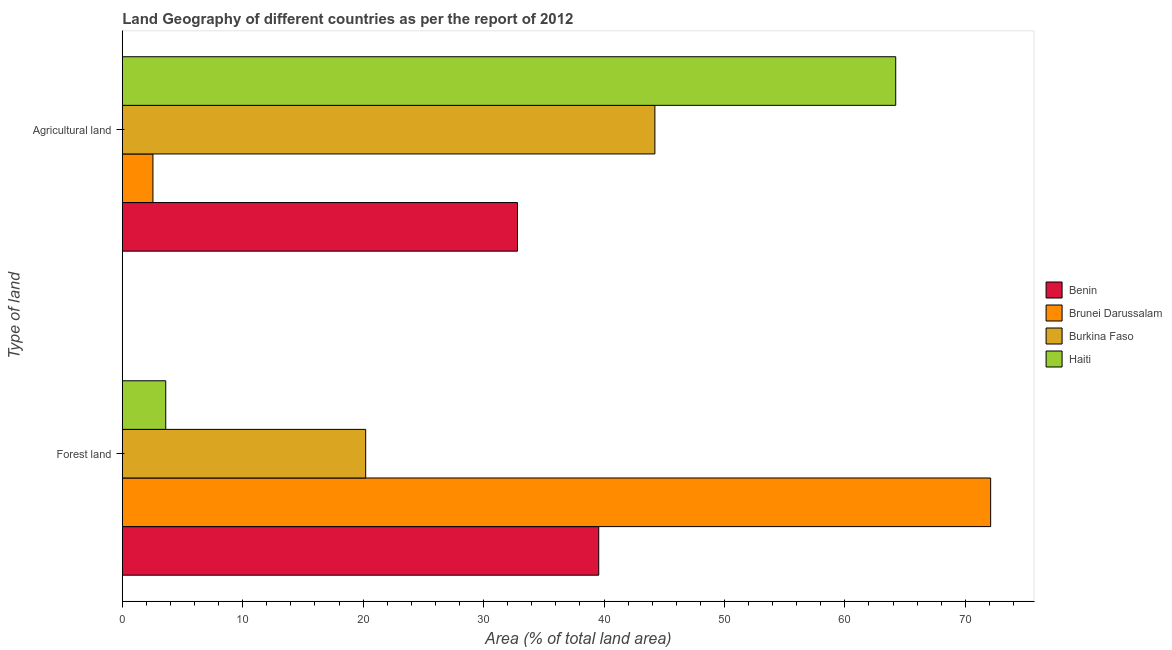How many groups of bars are there?
Give a very brief answer. 2. Are the number of bars on each tick of the Y-axis equal?
Provide a short and direct response. Yes. How many bars are there on the 1st tick from the bottom?
Your answer should be very brief. 4. What is the label of the 1st group of bars from the top?
Offer a terse response. Agricultural land. What is the percentage of land area under forests in Brunei Darussalam?
Give a very brief answer. 72.11. Across all countries, what is the maximum percentage of land area under agriculture?
Give a very brief answer. 64.22. Across all countries, what is the minimum percentage of land area under agriculture?
Offer a terse response. 2.54. In which country was the percentage of land area under agriculture maximum?
Offer a terse response. Haiti. In which country was the percentage of land area under forests minimum?
Your response must be concise. Haiti. What is the total percentage of land area under agriculture in the graph?
Your answer should be very brief. 143.8. What is the difference between the percentage of land area under agriculture in Burkina Faso and that in Haiti?
Your response must be concise. -20. What is the difference between the percentage of land area under forests in Burkina Faso and the percentage of land area under agriculture in Benin?
Offer a terse response. -12.6. What is the average percentage of land area under agriculture per country?
Offer a very short reply. 35.95. What is the difference between the percentage of land area under agriculture and percentage of land area under forests in Benin?
Provide a succinct answer. -6.75. In how many countries, is the percentage of land area under agriculture greater than 38 %?
Give a very brief answer. 2. What is the ratio of the percentage of land area under agriculture in Benin to that in Haiti?
Give a very brief answer. 0.51. What does the 4th bar from the top in Forest land represents?
Provide a short and direct response. Benin. What does the 1st bar from the bottom in Forest land represents?
Your answer should be very brief. Benin. How many bars are there?
Offer a terse response. 8. How many countries are there in the graph?
Your response must be concise. 4. Are the values on the major ticks of X-axis written in scientific E-notation?
Your answer should be very brief. No. Does the graph contain any zero values?
Your answer should be very brief. No. Does the graph contain grids?
Your response must be concise. No. Where does the legend appear in the graph?
Keep it short and to the point. Center right. How many legend labels are there?
Give a very brief answer. 4. How are the legend labels stacked?
Provide a succinct answer. Vertical. What is the title of the graph?
Make the answer very short. Land Geography of different countries as per the report of 2012. Does "Marshall Islands" appear as one of the legend labels in the graph?
Provide a succinct answer. No. What is the label or title of the X-axis?
Offer a terse response. Area (% of total land area). What is the label or title of the Y-axis?
Provide a short and direct response. Type of land. What is the Area (% of total land area) in Benin in Forest land?
Give a very brief answer. 39.56. What is the Area (% of total land area) of Brunei Darussalam in Forest land?
Provide a short and direct response. 72.11. What is the Area (% of total land area) in Burkina Faso in Forest land?
Your response must be concise. 20.21. What is the Area (% of total land area) of Haiti in Forest land?
Offer a terse response. 3.61. What is the Area (% of total land area) of Benin in Agricultural land?
Keep it short and to the point. 32.81. What is the Area (% of total land area) of Brunei Darussalam in Agricultural land?
Make the answer very short. 2.54. What is the Area (% of total land area) in Burkina Faso in Agricultural land?
Provide a succinct answer. 44.23. What is the Area (% of total land area) of Haiti in Agricultural land?
Ensure brevity in your answer.  64.22. Across all Type of land, what is the maximum Area (% of total land area) in Benin?
Make the answer very short. 39.56. Across all Type of land, what is the maximum Area (% of total land area) of Brunei Darussalam?
Your answer should be very brief. 72.11. Across all Type of land, what is the maximum Area (% of total land area) in Burkina Faso?
Your response must be concise. 44.23. Across all Type of land, what is the maximum Area (% of total land area) of Haiti?
Ensure brevity in your answer.  64.22. Across all Type of land, what is the minimum Area (% of total land area) of Benin?
Give a very brief answer. 32.81. Across all Type of land, what is the minimum Area (% of total land area) of Brunei Darussalam?
Your response must be concise. 2.54. Across all Type of land, what is the minimum Area (% of total land area) in Burkina Faso?
Make the answer very short. 20.21. Across all Type of land, what is the minimum Area (% of total land area) in Haiti?
Keep it short and to the point. 3.61. What is the total Area (% of total land area) of Benin in the graph?
Ensure brevity in your answer.  72.38. What is the total Area (% of total land area) in Brunei Darussalam in the graph?
Your response must be concise. 74.65. What is the total Area (% of total land area) in Burkina Faso in the graph?
Your response must be concise. 64.43. What is the total Area (% of total land area) in Haiti in the graph?
Keep it short and to the point. 67.83. What is the difference between the Area (% of total land area) in Benin in Forest land and that in Agricultural land?
Make the answer very short. 6.75. What is the difference between the Area (% of total land area) of Brunei Darussalam in Forest land and that in Agricultural land?
Your response must be concise. 69.56. What is the difference between the Area (% of total land area) of Burkina Faso in Forest land and that in Agricultural land?
Keep it short and to the point. -24.02. What is the difference between the Area (% of total land area) of Haiti in Forest land and that in Agricultural land?
Ensure brevity in your answer.  -60.62. What is the difference between the Area (% of total land area) in Benin in Forest land and the Area (% of total land area) in Brunei Darussalam in Agricultural land?
Your answer should be compact. 37.02. What is the difference between the Area (% of total land area) in Benin in Forest land and the Area (% of total land area) in Burkina Faso in Agricultural land?
Your answer should be compact. -4.66. What is the difference between the Area (% of total land area) of Benin in Forest land and the Area (% of total land area) of Haiti in Agricultural land?
Offer a terse response. -24.66. What is the difference between the Area (% of total land area) of Brunei Darussalam in Forest land and the Area (% of total land area) of Burkina Faso in Agricultural land?
Make the answer very short. 27.88. What is the difference between the Area (% of total land area) of Brunei Darussalam in Forest land and the Area (% of total land area) of Haiti in Agricultural land?
Ensure brevity in your answer.  7.88. What is the difference between the Area (% of total land area) in Burkina Faso in Forest land and the Area (% of total land area) in Haiti in Agricultural land?
Provide a succinct answer. -44.01. What is the average Area (% of total land area) in Benin per Type of land?
Offer a very short reply. 36.19. What is the average Area (% of total land area) in Brunei Darussalam per Type of land?
Provide a succinct answer. 37.32. What is the average Area (% of total land area) of Burkina Faso per Type of land?
Ensure brevity in your answer.  32.22. What is the average Area (% of total land area) of Haiti per Type of land?
Keep it short and to the point. 33.92. What is the difference between the Area (% of total land area) in Benin and Area (% of total land area) in Brunei Darussalam in Forest land?
Keep it short and to the point. -32.54. What is the difference between the Area (% of total land area) in Benin and Area (% of total land area) in Burkina Faso in Forest land?
Your response must be concise. 19.35. What is the difference between the Area (% of total land area) in Benin and Area (% of total land area) in Haiti in Forest land?
Provide a succinct answer. 35.96. What is the difference between the Area (% of total land area) of Brunei Darussalam and Area (% of total land area) of Burkina Faso in Forest land?
Your answer should be compact. 51.9. What is the difference between the Area (% of total land area) of Brunei Darussalam and Area (% of total land area) of Haiti in Forest land?
Offer a very short reply. 68.5. What is the difference between the Area (% of total land area) in Burkina Faso and Area (% of total land area) in Haiti in Forest land?
Provide a succinct answer. 16.6. What is the difference between the Area (% of total land area) in Benin and Area (% of total land area) in Brunei Darussalam in Agricultural land?
Make the answer very short. 30.27. What is the difference between the Area (% of total land area) in Benin and Area (% of total land area) in Burkina Faso in Agricultural land?
Your answer should be very brief. -11.41. What is the difference between the Area (% of total land area) in Benin and Area (% of total land area) in Haiti in Agricultural land?
Provide a short and direct response. -31.41. What is the difference between the Area (% of total land area) in Brunei Darussalam and Area (% of total land area) in Burkina Faso in Agricultural land?
Ensure brevity in your answer.  -41.68. What is the difference between the Area (% of total land area) of Brunei Darussalam and Area (% of total land area) of Haiti in Agricultural land?
Give a very brief answer. -61.68. What is the difference between the Area (% of total land area) in Burkina Faso and Area (% of total land area) in Haiti in Agricultural land?
Offer a very short reply. -20. What is the ratio of the Area (% of total land area) of Benin in Forest land to that in Agricultural land?
Offer a terse response. 1.21. What is the ratio of the Area (% of total land area) of Brunei Darussalam in Forest land to that in Agricultural land?
Make the answer very short. 28.36. What is the ratio of the Area (% of total land area) of Burkina Faso in Forest land to that in Agricultural land?
Ensure brevity in your answer.  0.46. What is the ratio of the Area (% of total land area) of Haiti in Forest land to that in Agricultural land?
Keep it short and to the point. 0.06. What is the difference between the highest and the second highest Area (% of total land area) in Benin?
Make the answer very short. 6.75. What is the difference between the highest and the second highest Area (% of total land area) in Brunei Darussalam?
Keep it short and to the point. 69.56. What is the difference between the highest and the second highest Area (% of total land area) of Burkina Faso?
Your answer should be very brief. 24.02. What is the difference between the highest and the second highest Area (% of total land area) of Haiti?
Provide a short and direct response. 60.62. What is the difference between the highest and the lowest Area (% of total land area) of Benin?
Give a very brief answer. 6.75. What is the difference between the highest and the lowest Area (% of total land area) in Brunei Darussalam?
Ensure brevity in your answer.  69.56. What is the difference between the highest and the lowest Area (% of total land area) in Burkina Faso?
Offer a very short reply. 24.02. What is the difference between the highest and the lowest Area (% of total land area) in Haiti?
Your answer should be compact. 60.62. 